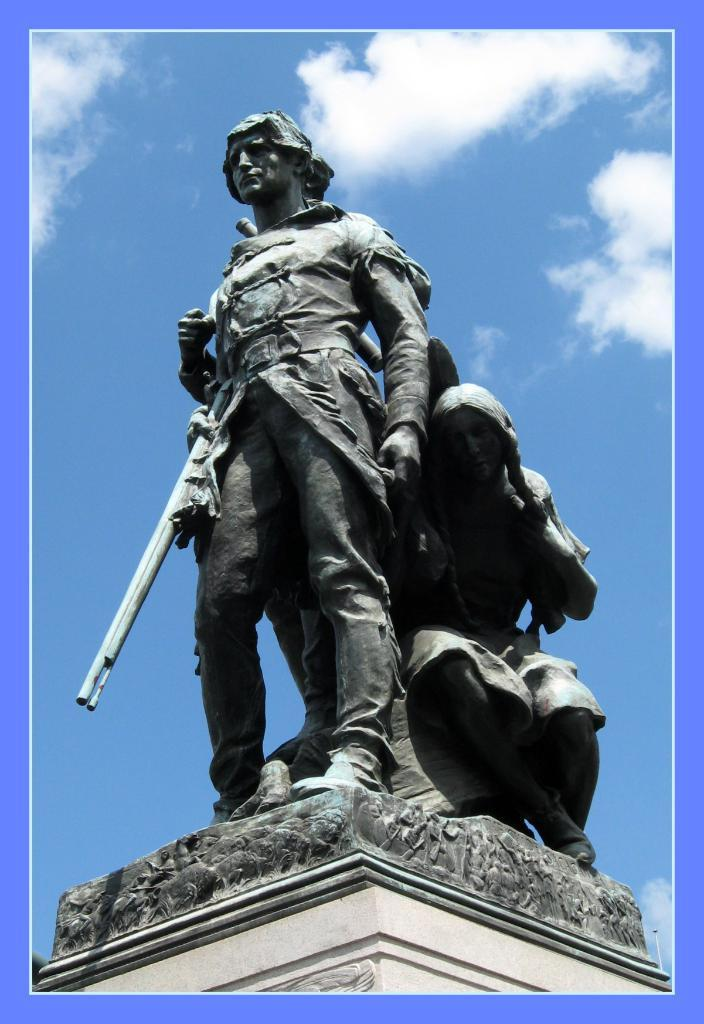What type of objects can be seen in the image? There are statues in the image. What can be seen in the background of the image? There are clouds in the background of the image. What type of sweater is the statue wearing in the image? The statues in the image are not wearing sweaters, as they are inanimate objects and do not wear clothing. 